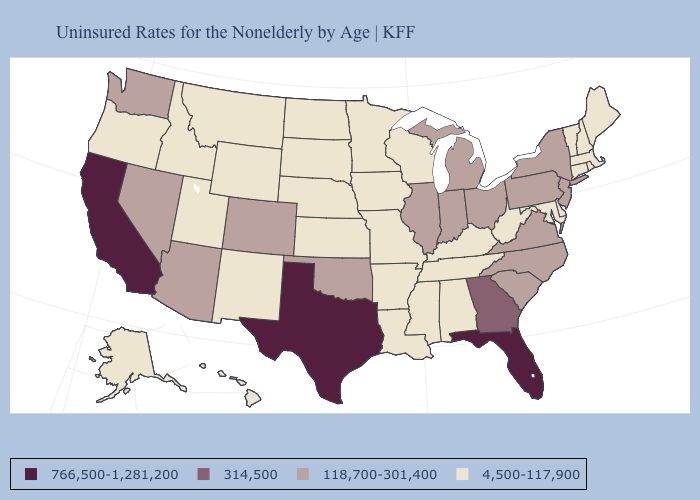Name the states that have a value in the range 118,700-301,400?
Quick response, please. Arizona, Colorado, Illinois, Indiana, Michigan, Nevada, New Jersey, New York, North Carolina, Ohio, Oklahoma, Pennsylvania, South Carolina, Virginia, Washington. Among the states that border Montana , which have the highest value?
Give a very brief answer. Idaho, North Dakota, South Dakota, Wyoming. Name the states that have a value in the range 4,500-117,900?
Write a very short answer. Alabama, Alaska, Arkansas, Connecticut, Delaware, Hawaii, Idaho, Iowa, Kansas, Kentucky, Louisiana, Maine, Maryland, Massachusetts, Minnesota, Mississippi, Missouri, Montana, Nebraska, New Hampshire, New Mexico, North Dakota, Oregon, Rhode Island, South Dakota, Tennessee, Utah, Vermont, West Virginia, Wisconsin, Wyoming. Name the states that have a value in the range 766,500-1,281,200?
Short answer required. California, Florida, Texas. How many symbols are there in the legend?
Short answer required. 4. Does California have the highest value in the USA?
Short answer required. Yes. Which states have the lowest value in the South?
Give a very brief answer. Alabama, Arkansas, Delaware, Kentucky, Louisiana, Maryland, Mississippi, Tennessee, West Virginia. Among the states that border Wyoming , does Montana have the highest value?
Quick response, please. No. Name the states that have a value in the range 314,500?
Write a very short answer. Georgia. What is the value of New York?
Be succinct. 118,700-301,400. What is the value of Oregon?
Write a very short answer. 4,500-117,900. Among the states that border Delaware , which have the lowest value?
Be succinct. Maryland. Name the states that have a value in the range 118,700-301,400?
Concise answer only. Arizona, Colorado, Illinois, Indiana, Michigan, Nevada, New Jersey, New York, North Carolina, Ohio, Oklahoma, Pennsylvania, South Carolina, Virginia, Washington. Name the states that have a value in the range 314,500?
Short answer required. Georgia. Does Maine have the lowest value in the USA?
Answer briefly. Yes. 